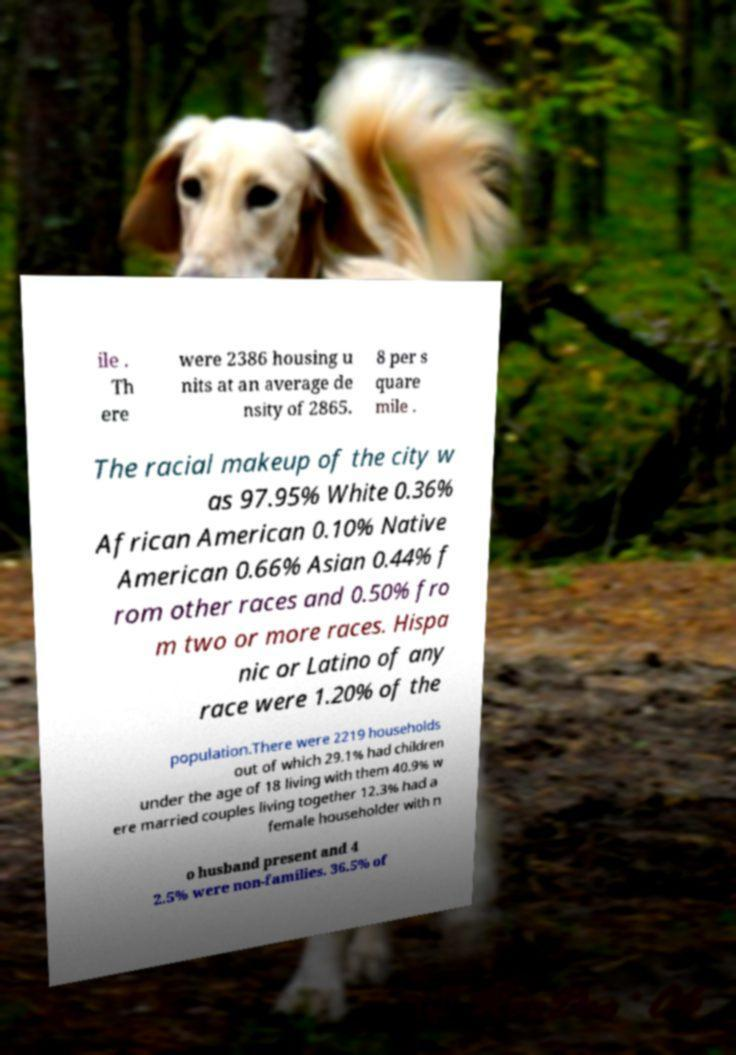Please identify and transcribe the text found in this image. ile . Th ere were 2386 housing u nits at an average de nsity of 2865. 8 per s quare mile . The racial makeup of the city w as 97.95% White 0.36% African American 0.10% Native American 0.66% Asian 0.44% f rom other races and 0.50% fro m two or more races. Hispa nic or Latino of any race were 1.20% of the population.There were 2219 households out of which 29.1% had children under the age of 18 living with them 40.9% w ere married couples living together 12.3% had a female householder with n o husband present and 4 2.5% were non-families. 36.5% of 